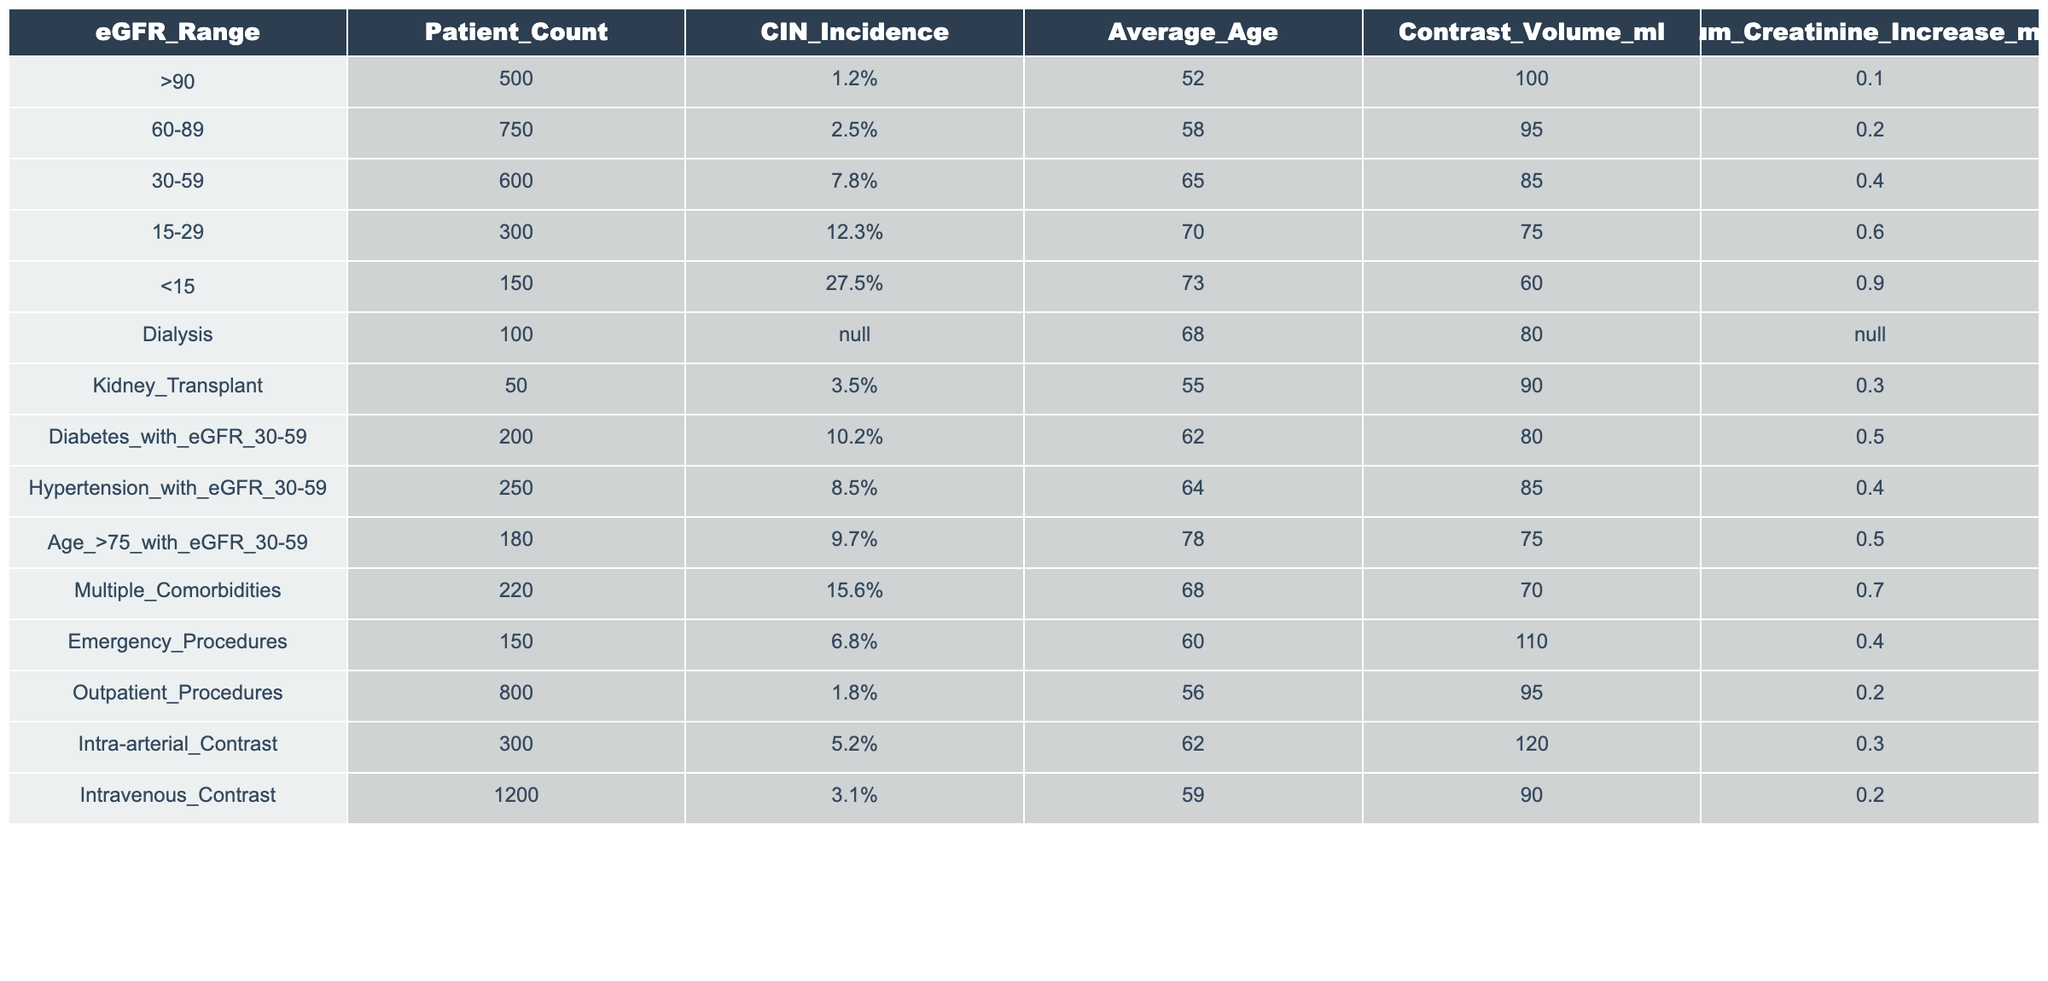What is the incidence of contrast-induced nephropathy (CIN) in patients with renal function eGFR less than 15? The table shows that for patients with eGFR less than 15, the CIN incidence is 27.5%.
Answer: 27.5% How many patients in the 30-59 eGFR range were observed? The table indicates that there are 600 patients with eGFR in the 30-59 range.
Answer: 600 Is the incidence of CIN higher in patients undergoing dialysis compared to patients with eGFR <15? The table lists the CIN incidence for dialysis patients as N/A, while it is 27.5% for patients with eGFR <15. Thus, we cannot compare, making the statement false.
Answer: False What is the average age of patients with an eGFR of 60-89? From the table, the average age for patients with eGFR 60-89 is 58 years.
Answer: 58 How does the incidence of CIN compare between patients with eGFR 15-29 and those with 30-59? The incidence for eGFR 15-29 is 12.3% and for eGFR 30-59 is 7.8%. Comparing these values shows the incidence is higher in the 15-29 group by 4.5%.
Answer: Higher by 4.5% What is the total number of patients with eGFR <30? The count of patients with eGFR 15-29 is 300 and with eGFR <15 is 150. Adding these gives 300 + 150 = 450 patients.
Answer: 450 In which eGFR range is the average increase in serum creatinine the highest? The table shows that the highest serum creatinine increase occurs in the eGFR <15 range at 0.9 mg/dl, confirming it is the highest among all groups.
Answer: eGFR <15 How many patients with multiple comorbidities experience CIN incidence above 10%? The CIN incidence for multiple comorbidities is 15.6%, which is above 10%. Therefore, 220 patients with multiple comorbidities are above this threshold.
Answer: 220 Calculate the difference in average age between patients with eGFR 30-59 and those with eGFR >90. The average age for eGFR 30-59 is 65, while for eGFR >90 it is 52. The difference is 65 - 52 = 13 years.
Answer: 13 Which group has the highest incidence of CIN? The group with eGFR <15 has the highest incidence of 27.5%, as per the table.
Answer: eGFR <15 If the contrast volume is constantly 100 ml, how many patients have a higher volume? The table indicates that 750 patients in the 60-89 range have a contrast volume of 95 ml, and 600 patients in the 30-59 range have 85 ml or lower, meaning 0 patients exceed 100 ml.
Answer: 0 